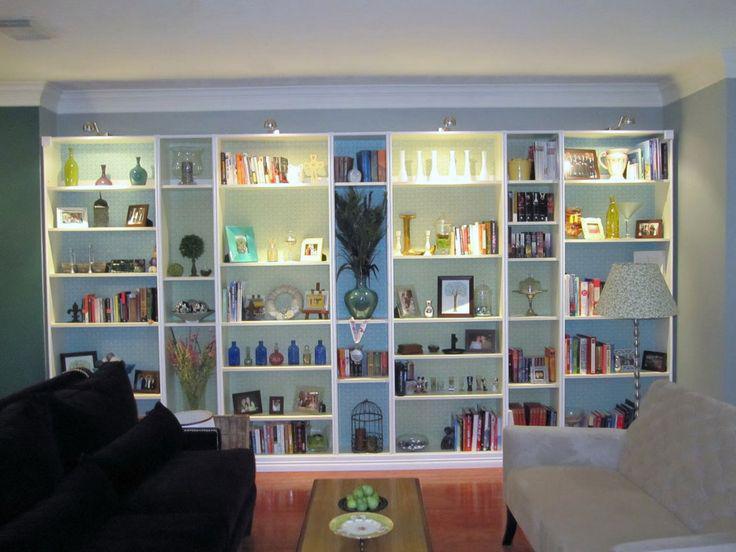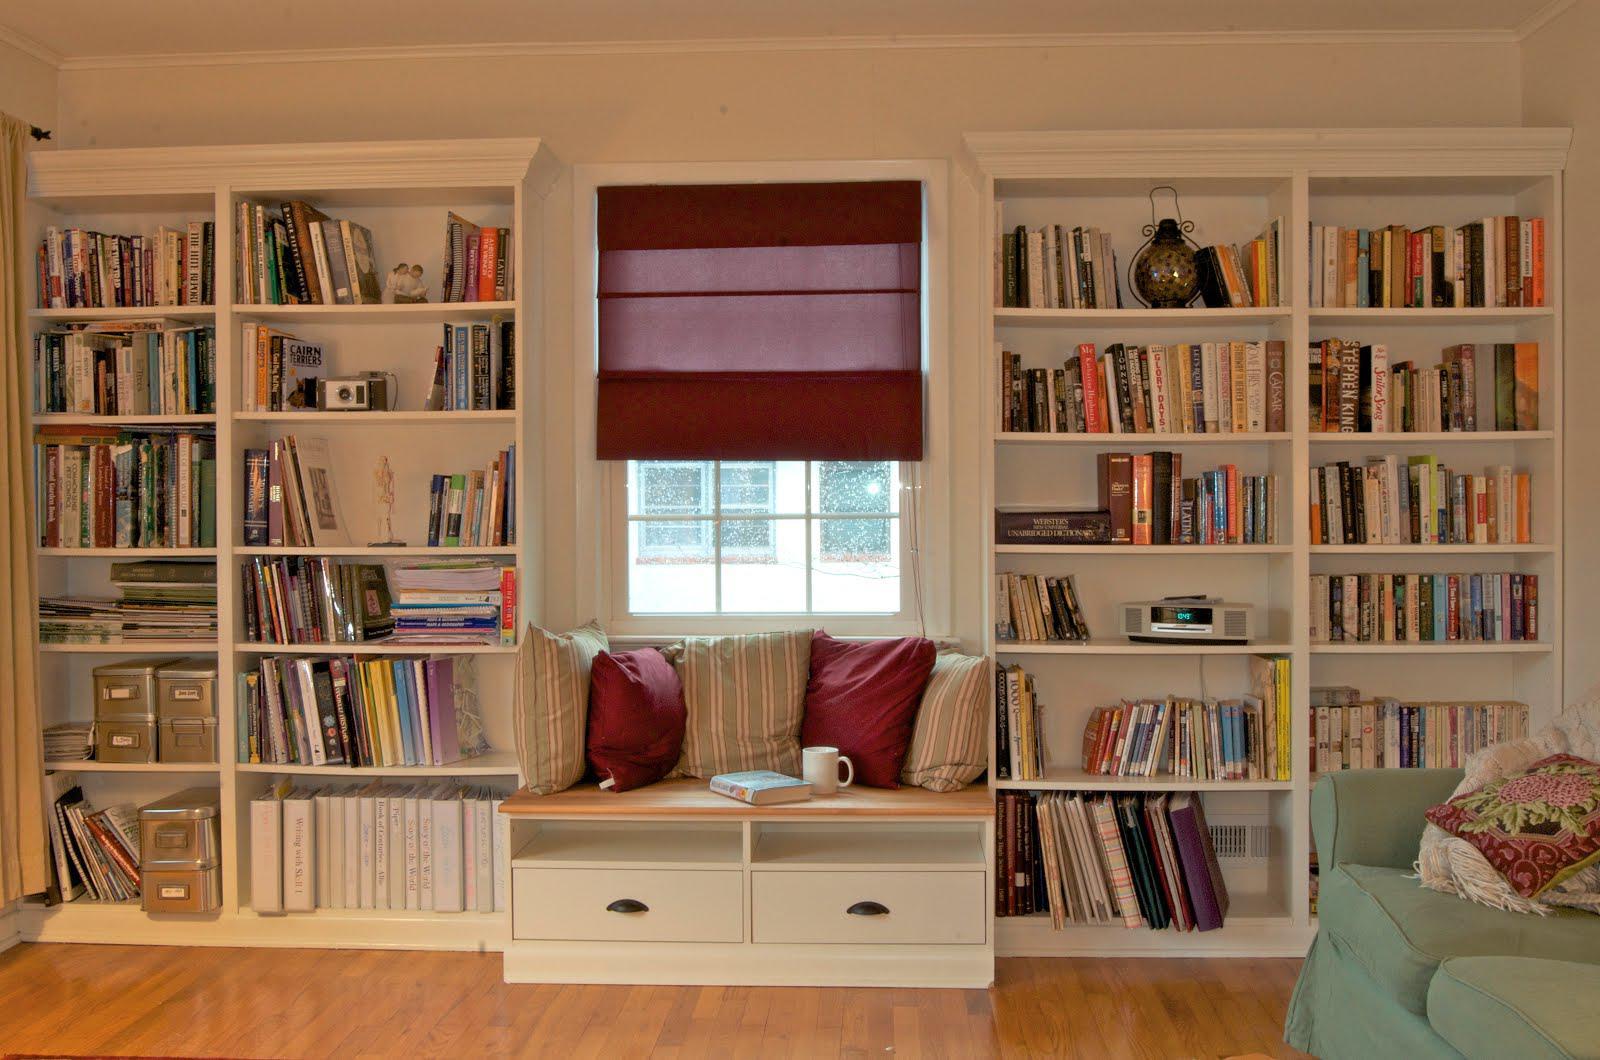The first image is the image on the left, the second image is the image on the right. Assess this claim about the two images: "One set of shelves has a built in window bench.". Correct or not? Answer yes or no. Yes. 